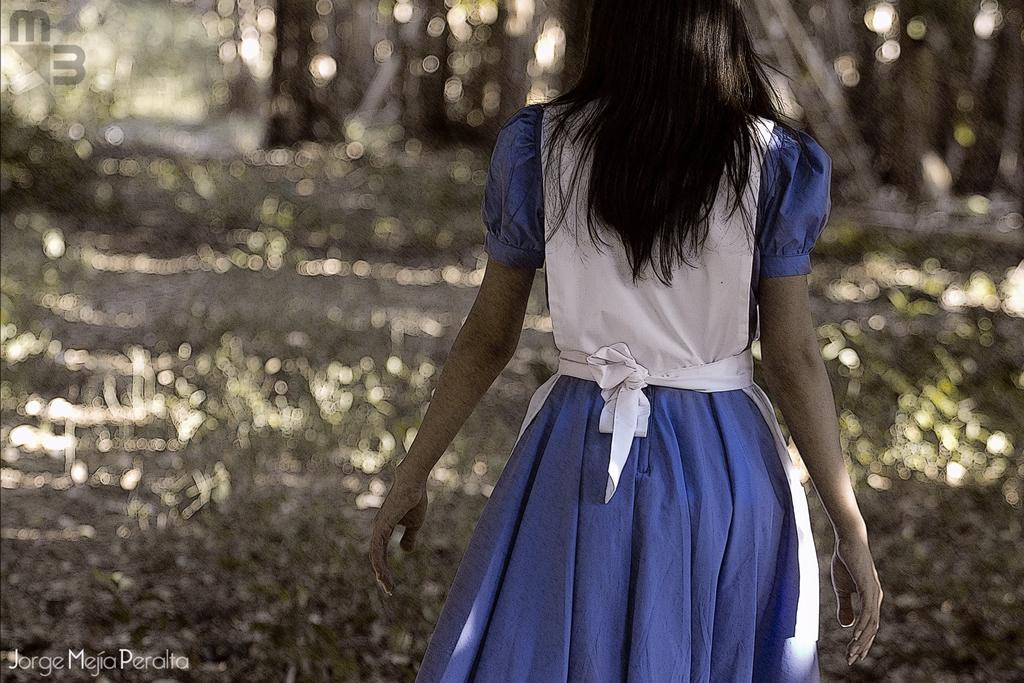Can you describe this image briefly? In the foreground of the picture there is a woman walking. In the background there are trees. 